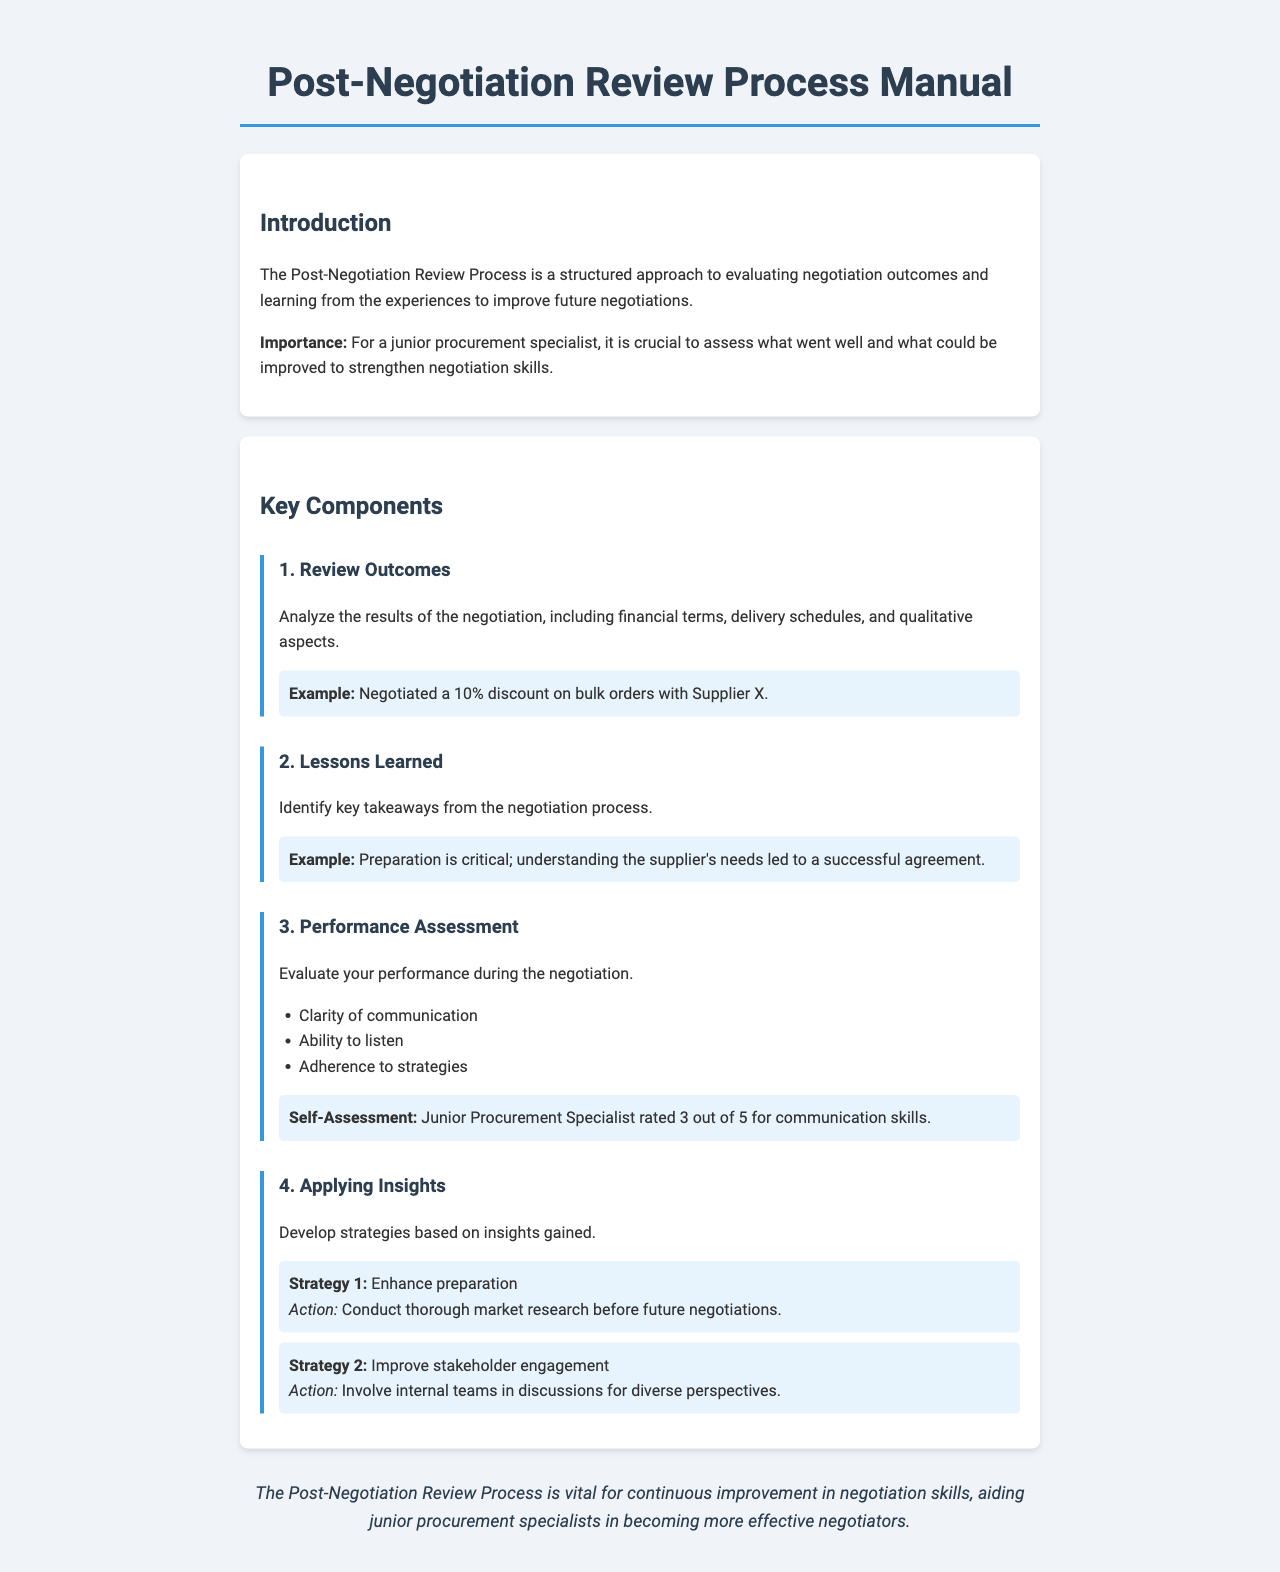What is the title of the manual? The title of the manual is presented prominently at the beginning of the document, which is "Post-Negotiation Review Process Manual."
Answer: Post-Negotiation Review Process Manual What is the first key component of the Post-Negotiation Review Process? The document lists the key components in a specific order, with the first being "Review Outcomes."
Answer: Review Outcomes What percentage discount was negotiated with Supplier X? The document provides an example of a negotiation outcome that included a specific percentage, which is 10%.
Answer: 10% What self-assessment score did the junior procurement specialist give for communication skills? The performance assessment section includes a specific self-rating given by the junior procurement specialist, which is out of 5.
Answer: 3 out of 5 What is one action to enhance preparation? The strategies section outlines specific actions, and one mentioned is to "Conduct thorough market research before future negotiations."
Answer: Conduct thorough market research What is the importance of the Post-Negotiation Review Process for a junior procurement specialist? The introduction emphasizes the significance of this process for the junior procurement specialist in assessing improvements needed in negotiation skills.
Answer: Strengthen negotiation skills How many strategies for applying insights are mentioned in the document? The strategies section lists the number of strategies formulated from the insights gained, which are two.
Answer: 2 What key takeaway from the lessons learned emphasizes as critical for success? The lessons learned section includes a specific takeaway highlighting the importance of understanding the supplier's needs for a successful agreement.
Answer: Preparation is critical 